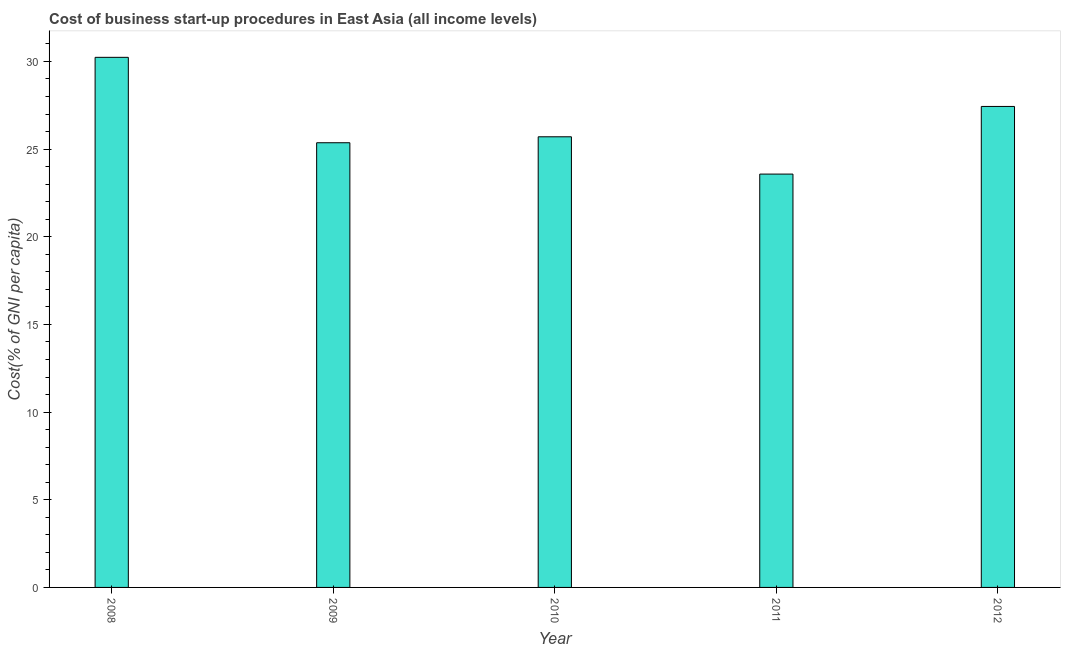Does the graph contain any zero values?
Make the answer very short. No. Does the graph contain grids?
Your answer should be compact. No. What is the title of the graph?
Make the answer very short. Cost of business start-up procedures in East Asia (all income levels). What is the label or title of the Y-axis?
Keep it short and to the point. Cost(% of GNI per capita). What is the cost of business startup procedures in 2009?
Make the answer very short. 25.36. Across all years, what is the maximum cost of business startup procedures?
Offer a very short reply. 30.24. Across all years, what is the minimum cost of business startup procedures?
Offer a terse response. 23.58. In which year was the cost of business startup procedures minimum?
Your answer should be compact. 2011. What is the sum of the cost of business startup procedures?
Make the answer very short. 132.31. What is the difference between the cost of business startup procedures in 2011 and 2012?
Make the answer very short. -3.86. What is the average cost of business startup procedures per year?
Your response must be concise. 26.46. What is the median cost of business startup procedures?
Your response must be concise. 25.7. In how many years, is the cost of business startup procedures greater than 20 %?
Give a very brief answer. 5. Do a majority of the years between 2009 and 2012 (inclusive) have cost of business startup procedures greater than 19 %?
Keep it short and to the point. Yes. What is the ratio of the cost of business startup procedures in 2008 to that in 2011?
Your answer should be very brief. 1.28. Is the cost of business startup procedures in 2011 less than that in 2012?
Give a very brief answer. Yes. What is the difference between the highest and the second highest cost of business startup procedures?
Your response must be concise. 2.8. Is the sum of the cost of business startup procedures in 2009 and 2012 greater than the maximum cost of business startup procedures across all years?
Your answer should be very brief. Yes. What is the difference between the highest and the lowest cost of business startup procedures?
Keep it short and to the point. 6.66. In how many years, is the cost of business startup procedures greater than the average cost of business startup procedures taken over all years?
Make the answer very short. 2. How many bars are there?
Provide a succinct answer. 5. Are all the bars in the graph horizontal?
Offer a very short reply. No. What is the difference between two consecutive major ticks on the Y-axis?
Keep it short and to the point. 5. Are the values on the major ticks of Y-axis written in scientific E-notation?
Your response must be concise. No. What is the Cost(% of GNI per capita) in 2008?
Ensure brevity in your answer.  30.24. What is the Cost(% of GNI per capita) in 2009?
Offer a very short reply. 25.36. What is the Cost(% of GNI per capita) of 2010?
Provide a short and direct response. 25.7. What is the Cost(% of GNI per capita) of 2011?
Offer a terse response. 23.58. What is the Cost(% of GNI per capita) in 2012?
Offer a very short reply. 27.43. What is the difference between the Cost(% of GNI per capita) in 2008 and 2009?
Make the answer very short. 4.87. What is the difference between the Cost(% of GNI per capita) in 2008 and 2010?
Your response must be concise. 4.53. What is the difference between the Cost(% of GNI per capita) in 2008 and 2011?
Give a very brief answer. 6.66. What is the difference between the Cost(% of GNI per capita) in 2008 and 2012?
Ensure brevity in your answer.  2.8. What is the difference between the Cost(% of GNI per capita) in 2009 and 2010?
Provide a succinct answer. -0.34. What is the difference between the Cost(% of GNI per capita) in 2009 and 2011?
Keep it short and to the point. 1.79. What is the difference between the Cost(% of GNI per capita) in 2009 and 2012?
Make the answer very short. -2.07. What is the difference between the Cost(% of GNI per capita) in 2010 and 2011?
Give a very brief answer. 2.13. What is the difference between the Cost(% of GNI per capita) in 2010 and 2012?
Provide a succinct answer. -1.73. What is the difference between the Cost(% of GNI per capita) in 2011 and 2012?
Offer a terse response. -3.86. What is the ratio of the Cost(% of GNI per capita) in 2008 to that in 2009?
Your answer should be very brief. 1.19. What is the ratio of the Cost(% of GNI per capita) in 2008 to that in 2010?
Offer a very short reply. 1.18. What is the ratio of the Cost(% of GNI per capita) in 2008 to that in 2011?
Make the answer very short. 1.28. What is the ratio of the Cost(% of GNI per capita) in 2008 to that in 2012?
Provide a short and direct response. 1.1. What is the ratio of the Cost(% of GNI per capita) in 2009 to that in 2011?
Offer a very short reply. 1.08. What is the ratio of the Cost(% of GNI per capita) in 2009 to that in 2012?
Ensure brevity in your answer.  0.93. What is the ratio of the Cost(% of GNI per capita) in 2010 to that in 2011?
Ensure brevity in your answer.  1.09. What is the ratio of the Cost(% of GNI per capita) in 2010 to that in 2012?
Your answer should be compact. 0.94. What is the ratio of the Cost(% of GNI per capita) in 2011 to that in 2012?
Ensure brevity in your answer.  0.86. 